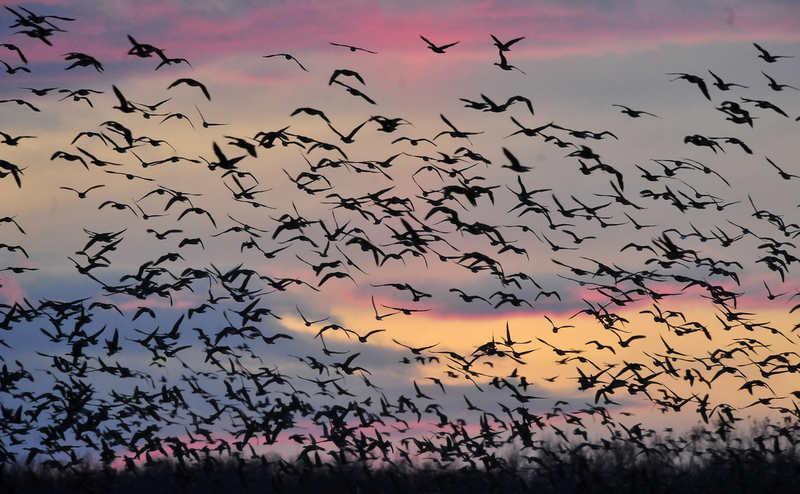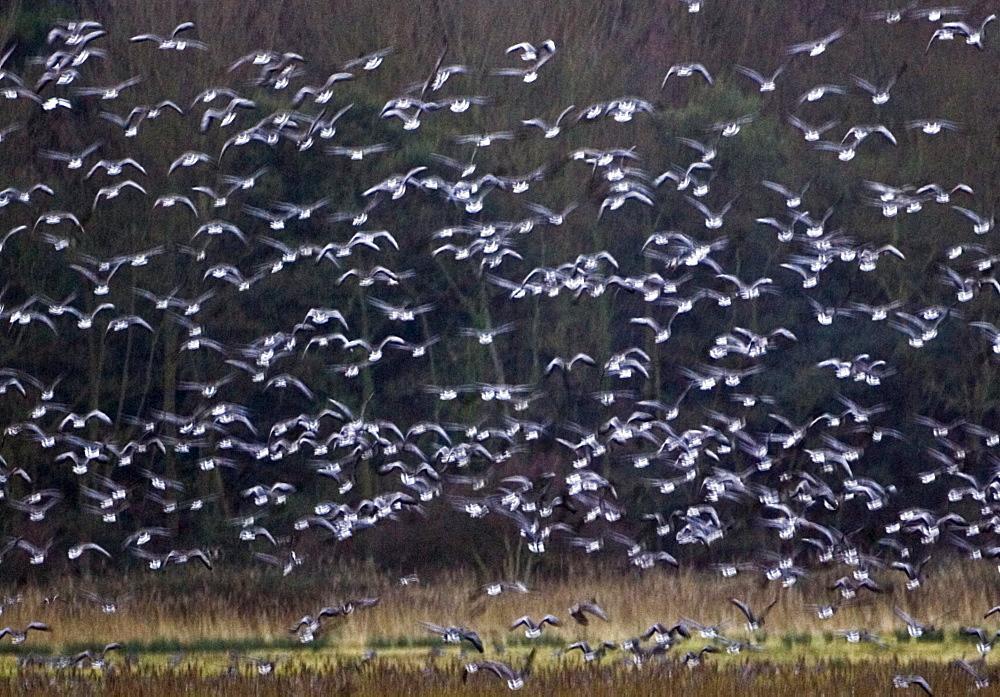The first image is the image on the left, the second image is the image on the right. Evaluate the accuracy of this statement regarding the images: "There are at least 100 white bird sitting on the ground with at least 2 gray crane walking across the field.". Is it true? Answer yes or no. No. The first image is the image on the left, the second image is the image on the right. Given the left and right images, does the statement "The left image includes a body of water with some birds in the water." hold true? Answer yes or no. No. 